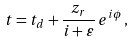Convert formula to latex. <formula><loc_0><loc_0><loc_500><loc_500>t = t _ { d } + \frac { z _ { r } } { i + \varepsilon } \, e ^ { i \phi } \, ,</formula> 